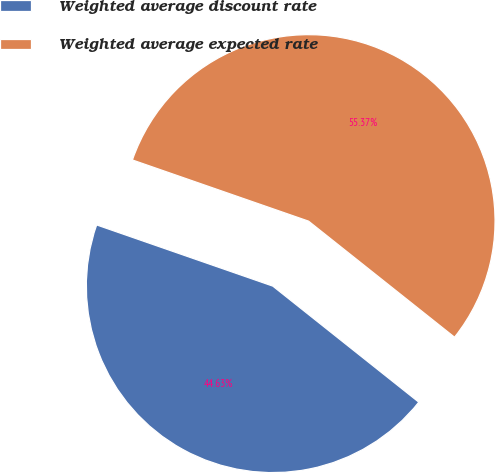Convert chart to OTSL. <chart><loc_0><loc_0><loc_500><loc_500><pie_chart><fcel>Weighted average discount rate<fcel>Weighted average expected rate<nl><fcel>44.63%<fcel>55.37%<nl></chart> 